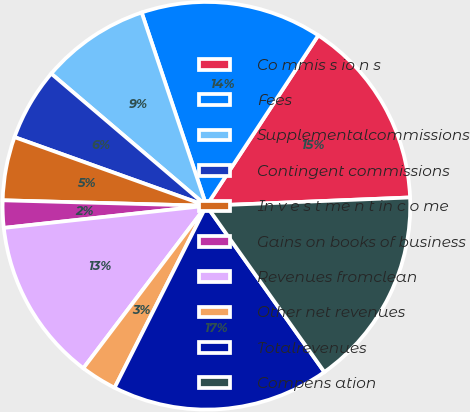Convert chart. <chart><loc_0><loc_0><loc_500><loc_500><pie_chart><fcel>Co mmis s io n s<fcel>Fees<fcel>Supplementalcommissions<fcel>Contingent commissions<fcel>In v e s t me n t in c o me<fcel>Gains on books of business<fcel>Revenues fromclean<fcel>Other net revenues<fcel>Totalrevenues<fcel>Compens ation<nl><fcel>15.11%<fcel>14.39%<fcel>8.63%<fcel>5.76%<fcel>5.04%<fcel>2.16%<fcel>12.95%<fcel>2.88%<fcel>17.26%<fcel>15.83%<nl></chart> 